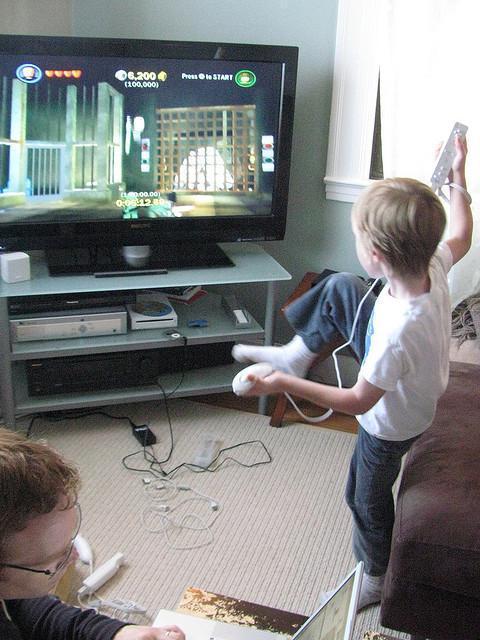How many children are wearing glasses?
Give a very brief answer. 1. How many laptops can be seen?
Give a very brief answer. 2. How many people are there?
Give a very brief answer. 2. 